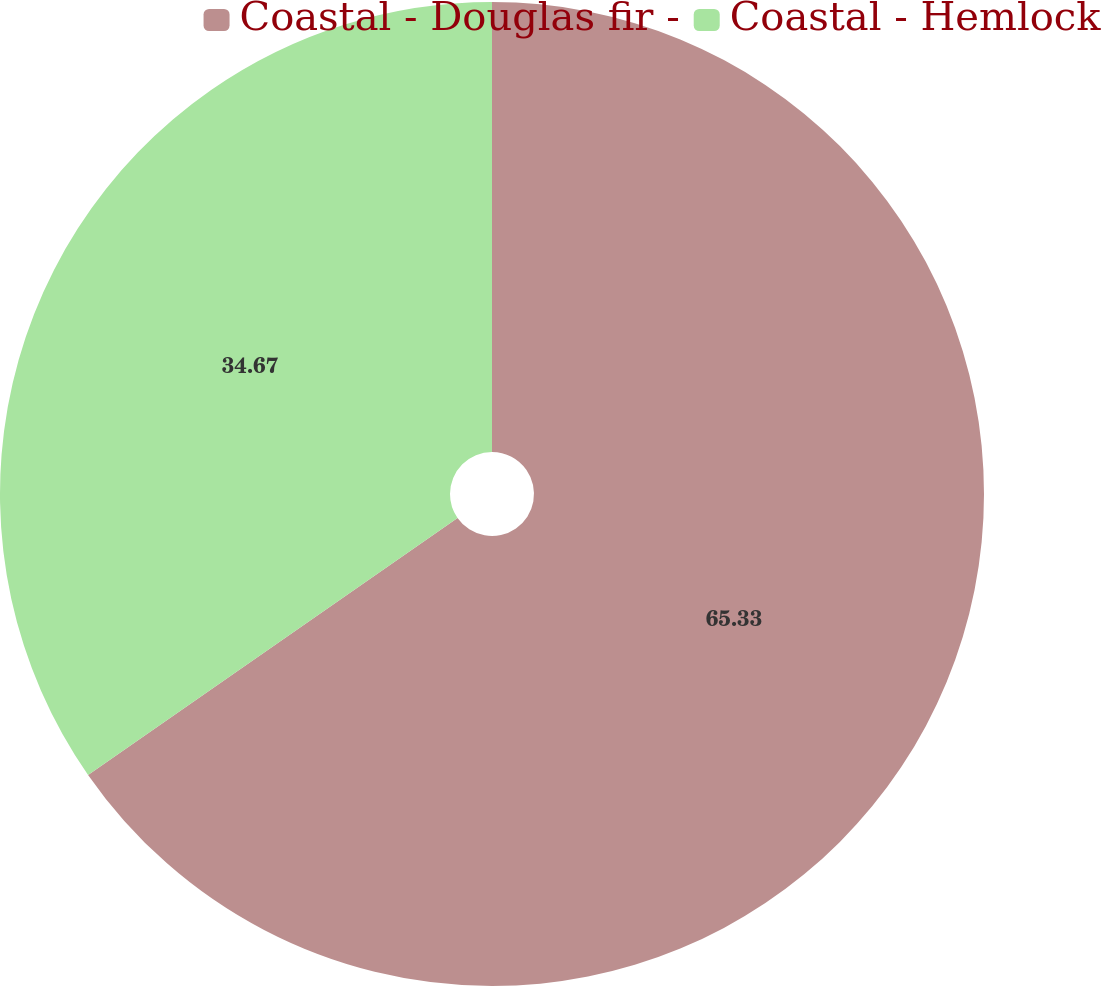Convert chart. <chart><loc_0><loc_0><loc_500><loc_500><pie_chart><fcel>Coastal - Douglas fir -<fcel>Coastal - Hemlock<nl><fcel>65.33%<fcel>34.67%<nl></chart> 